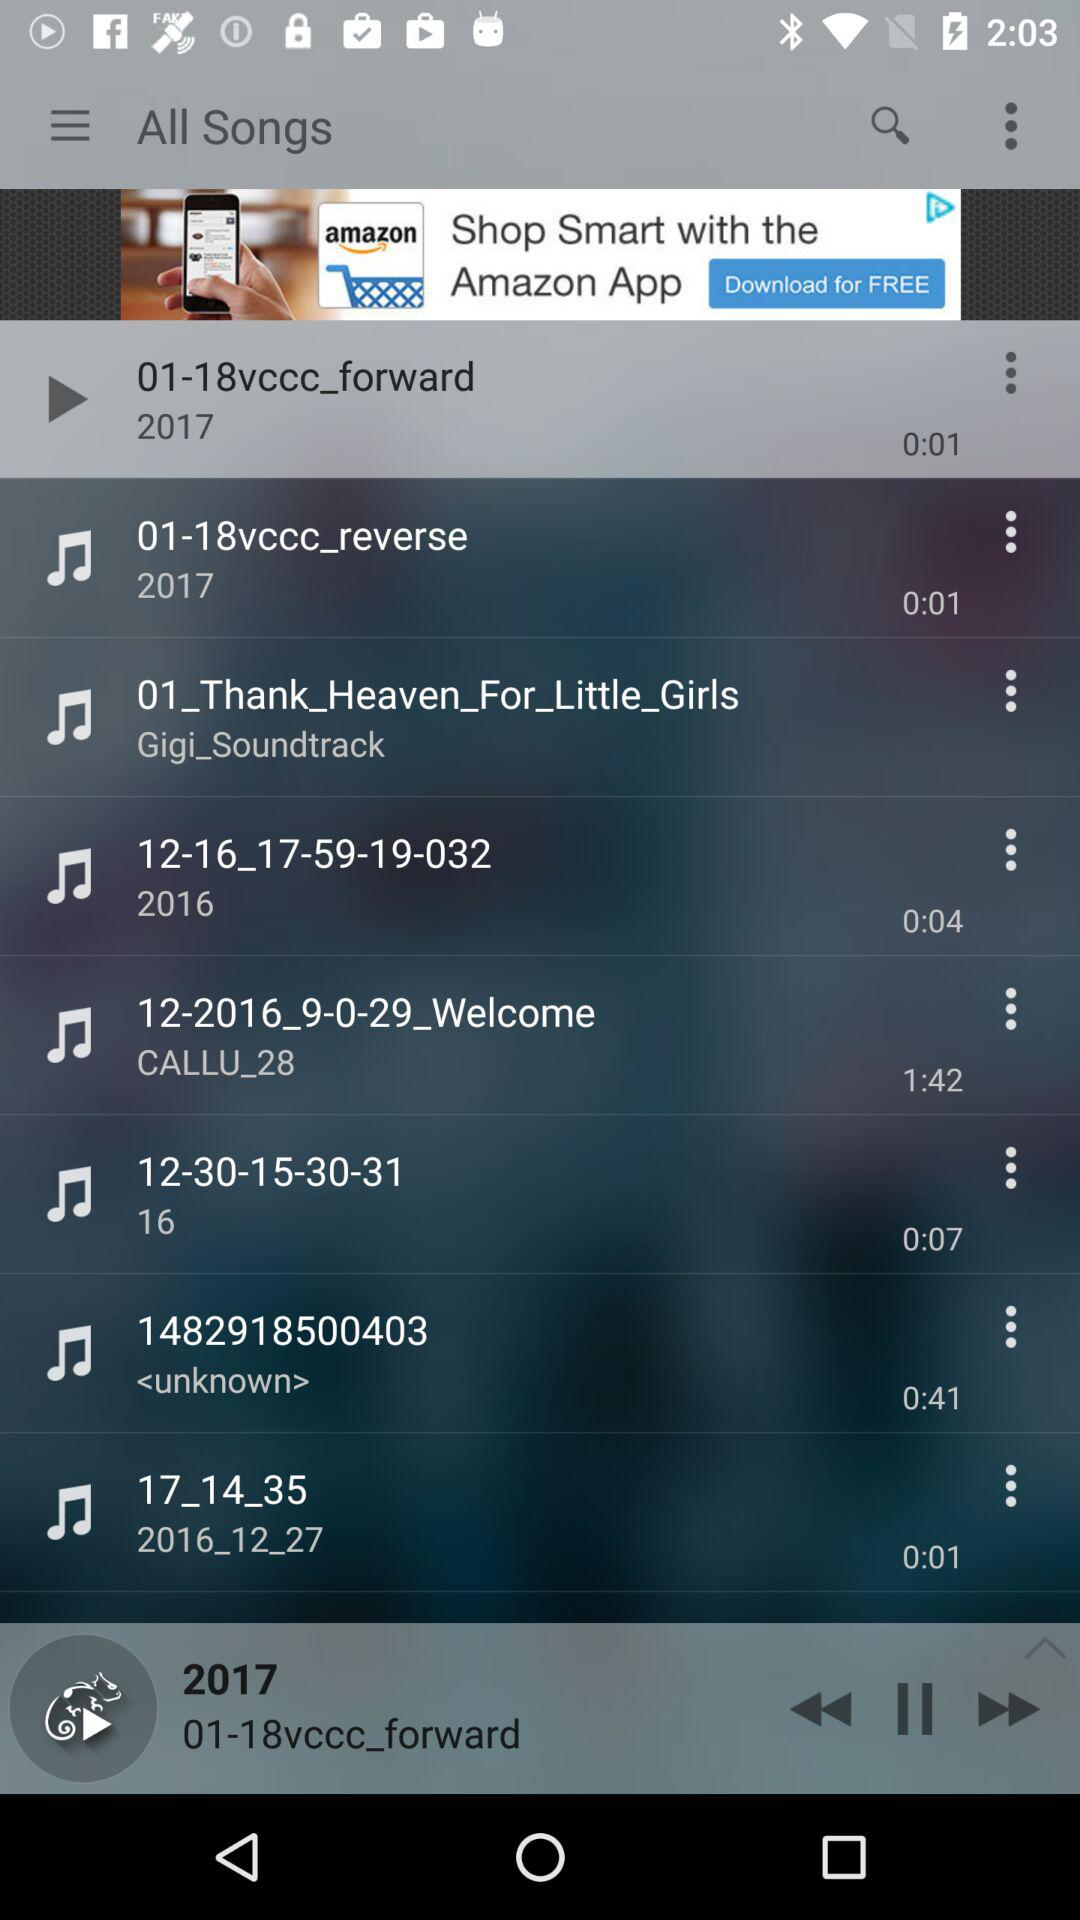Which audio is currently playing? The audio that is currently playing is "01-18vccc_forward". 